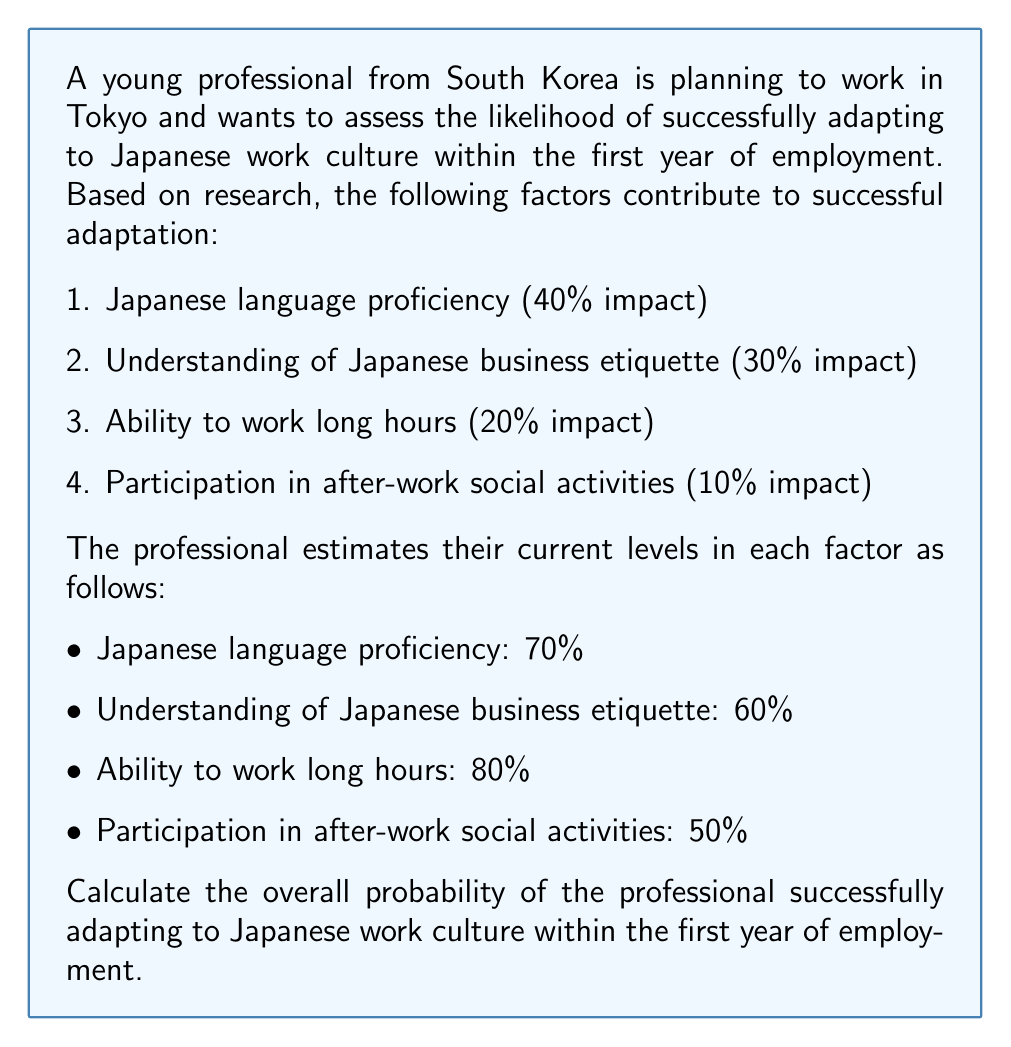Can you answer this question? To solve this problem, we need to calculate the weighted average of the professional's current levels in each factor, using the given impact percentages as weights. Let's break it down step-by-step:

1. Japanese language proficiency:
   Weight: 40% = 0.40
   Current level: 70% = 0.70
   Weighted contribution: $0.40 \times 0.70 = 0.28$

2. Understanding of Japanese business etiquette:
   Weight: 30% = 0.30
   Current level: 60% = 0.60
   Weighted contribution: $0.30 \times 0.60 = 0.18$

3. Ability to work long hours:
   Weight: 20% = 0.20
   Current level: 80% = 0.80
   Weighted contribution: $0.20 \times 0.80 = 0.16$

4. Participation in after-work social activities:
   Weight: 10% = 0.10
   Current level: 50% = 0.50
   Weighted contribution: $0.10 \times 0.50 = 0.05$

Now, we sum up all the weighted contributions to get the overall probability:

$$P(\text{successful adaptation}) = 0.28 + 0.18 + 0.16 + 0.05 = 0.67$$

To express this as a percentage, we multiply by 100:

$$P(\text{successful adaptation}) = 0.67 \times 100\% = 67\%$$
Answer: The overall probability of the young professional from South Korea successfully adapting to Japanese work culture within the first year of employment is 67%. 